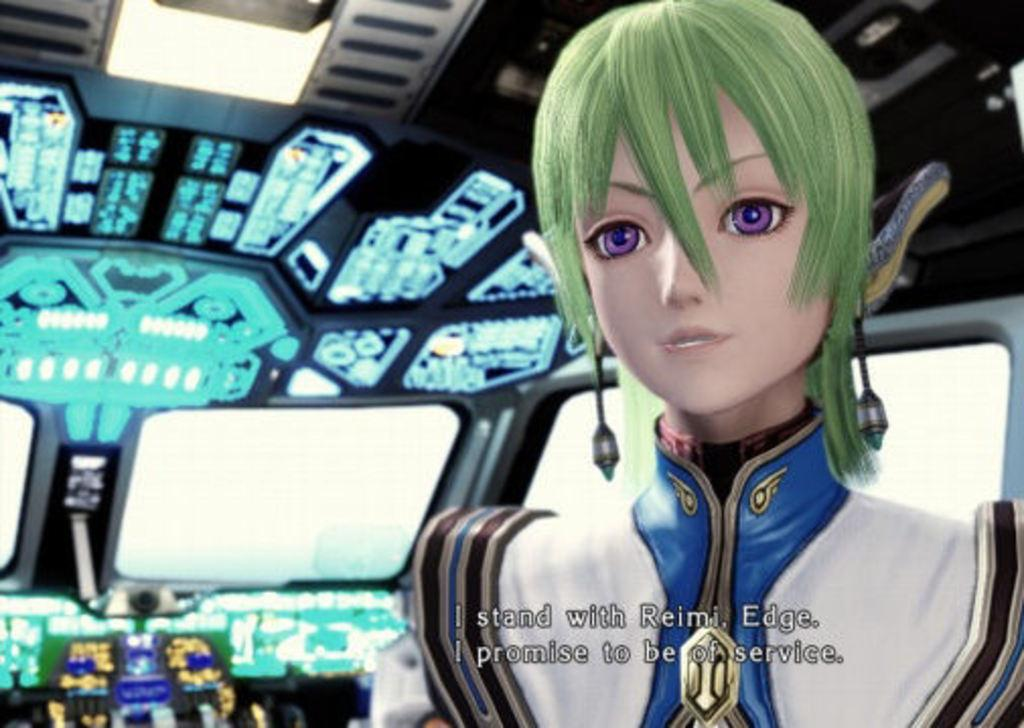<image>
Summarize the visual content of the image. Video game screen that says "Reimi" on it. 